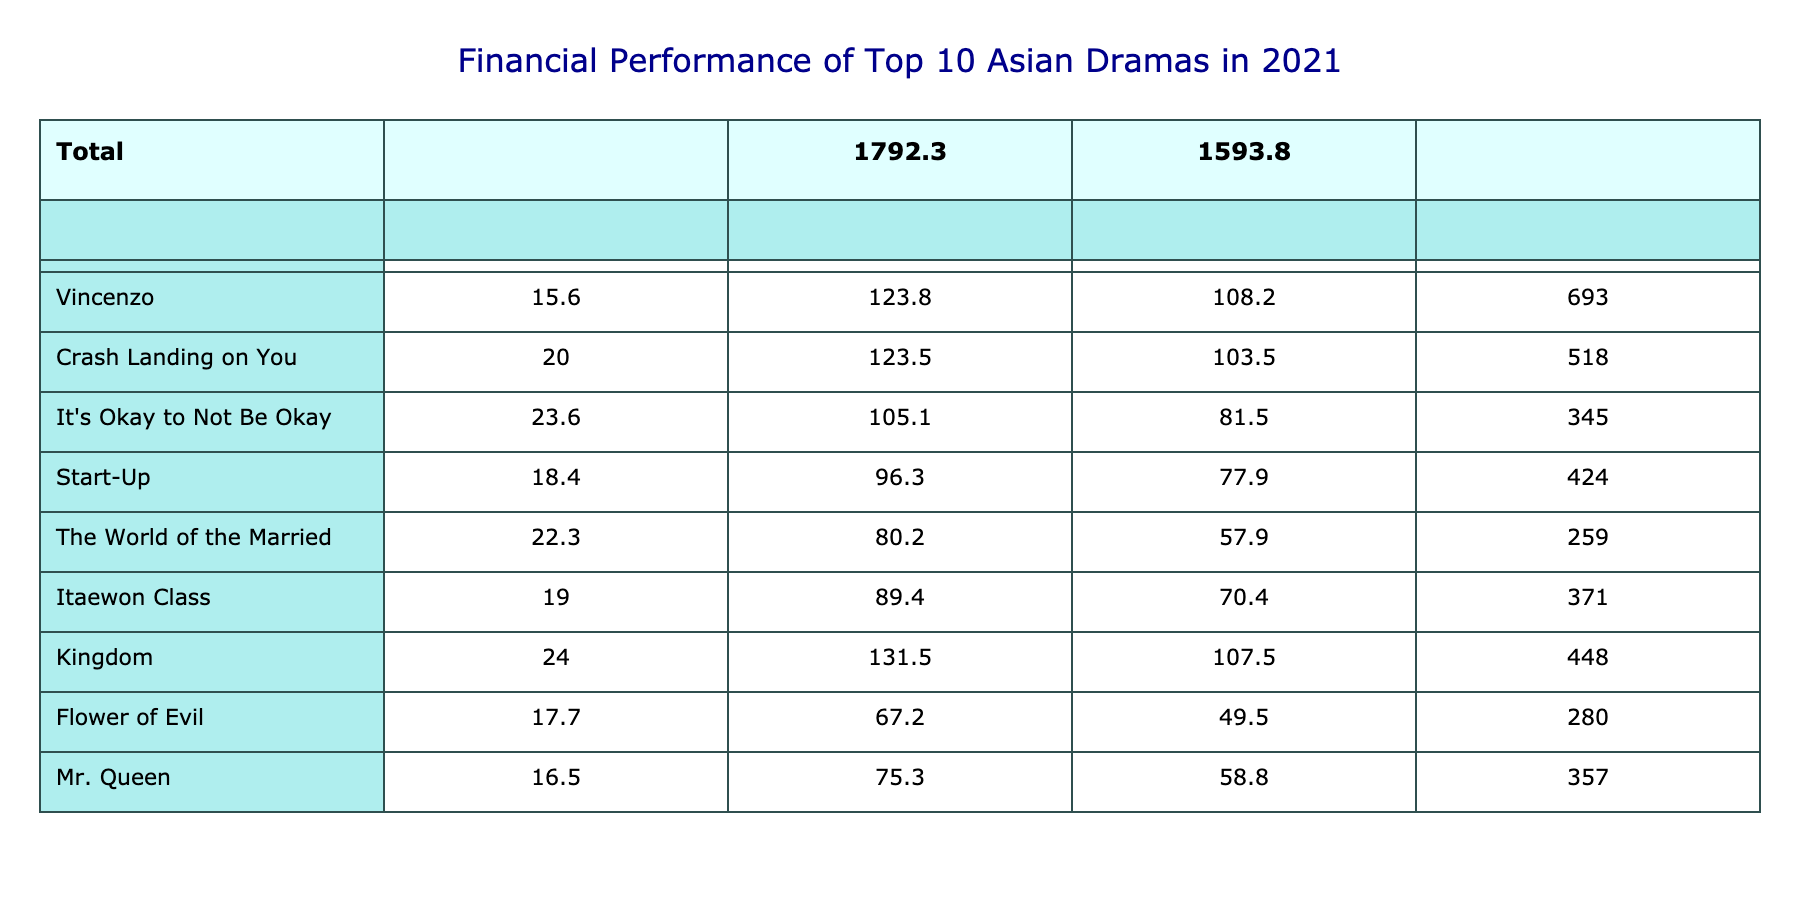What is the production cost of "Crash Landing on You"? The production cost of "Crash Landing on You" is listed directly in the table as 20.0 million USD.
Answer: 20.0 million USD Which drama has the highest profit margin? By looking at the profit margin column, "Squid Game" has the highest profit margin at 4104%.
Answer: Squid Game What is the average production cost of the dramas listed? To find the average production cost, I sum all the production costs (21.4 + 15.6 + 20.0 + 23.6 + 18.4 + 22.3 + 19.0 + 24.0 + 17.7 + 16.5 =  17.4). Then, I divide this total by the number of dramas, which is 10, resulting in an average of 19.6 million USD.
Answer: 19.6 million USD Is "Flower of Evil" more profitable than "It's Okay to Not Be Okay"? The profit for "Flower of Evil" is calculated by subtracting the production cost from revenue, which is 67.2 - 17.7 = 49.5 million USD. For "It's Okay to Not Be Okay," it's 105.1 - 23.6 = 81.5 million USD. Since 49.5 million USD is less than 81.5 million USD, "Flower of Evil" is not more profitable.
Answer: No If we combine the revenue of the top three dramas, what is the total? The total revenue of the top three dramas ("Squid Game," "Vincenzo," and "Crash Landing on You") is calculated as follows: 900 + 123.8 + 123.5 = 1147.3 million USD.
Answer: 1147.3 million USD Which drama had both a lower production cost and revenue than "Mr. Queen"? "Mr. Queen" has a production cost of 16.5 million USD and revenue of 75.3 million USD. By comparing, "Flower of Evil" (17.7 million USD, 67.2 million USD) has both lower production cost and revenue than "Mr. Queen".
Answer: Flower of Evil What is the total profit across all the dramas? To find the total profit, I calculate the profit for each drama (Revenue - Production Cost). Summing these profits gives: (900 - 21.4) + (123.8 - 15.6) + (123.5 - 20.0) + (105.1 - 23.6) + (96.3 - 18.4) + (80.2 - 22.3) + (89.4 - 19.0) + (131.5 - 24.0) + (67.2 - 17.7) + (75.3 - 16.5) =  1093.1 million USD.
Answer: 1093.1 million USD 